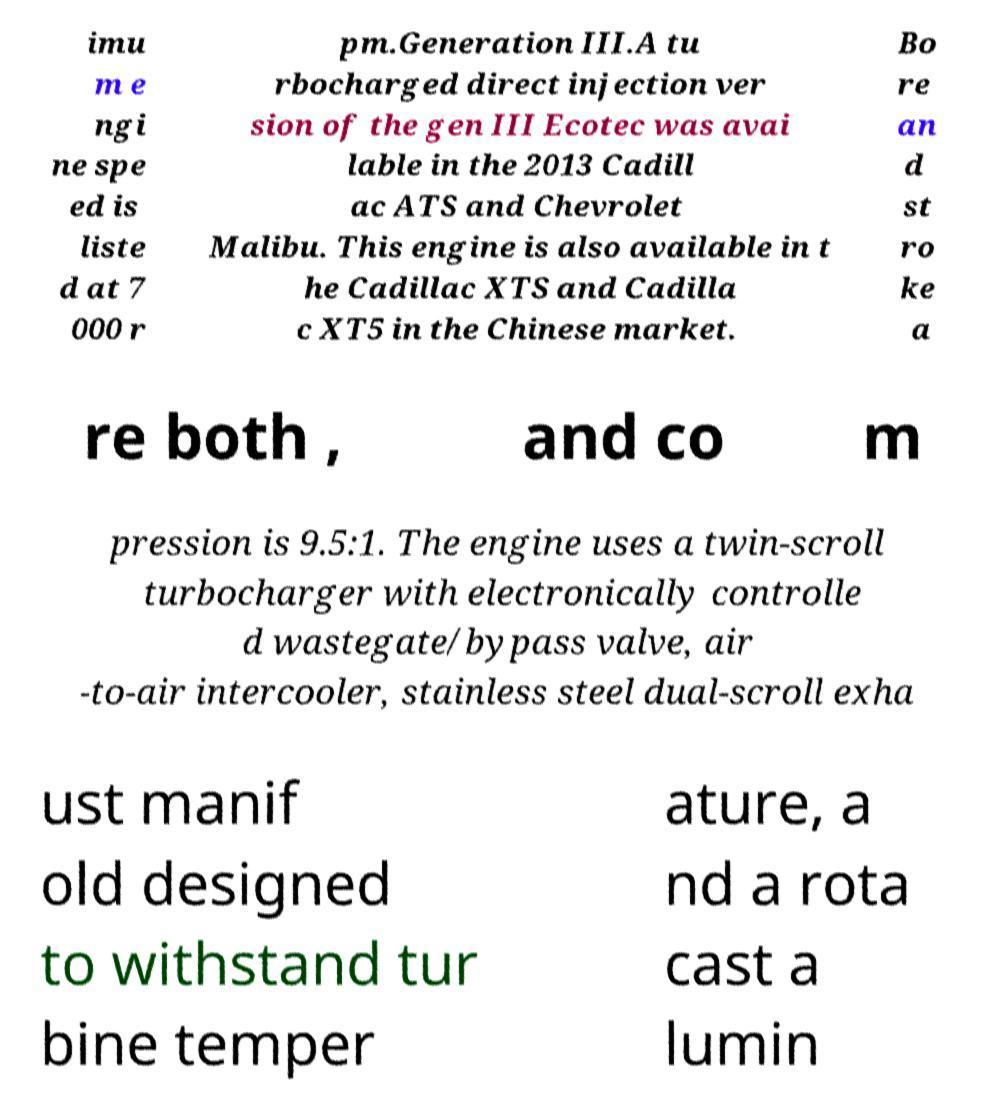Please identify and transcribe the text found in this image. imu m e ngi ne spe ed is liste d at 7 000 r pm.Generation III.A tu rbocharged direct injection ver sion of the gen III Ecotec was avai lable in the 2013 Cadill ac ATS and Chevrolet Malibu. This engine is also available in t he Cadillac XTS and Cadilla c XT5 in the Chinese market. Bo re an d st ro ke a re both , and co m pression is 9.5:1. The engine uses a twin-scroll turbocharger with electronically controlle d wastegate/bypass valve, air -to-air intercooler, stainless steel dual-scroll exha ust manif old designed to withstand tur bine temper ature, a nd a rota cast a lumin 